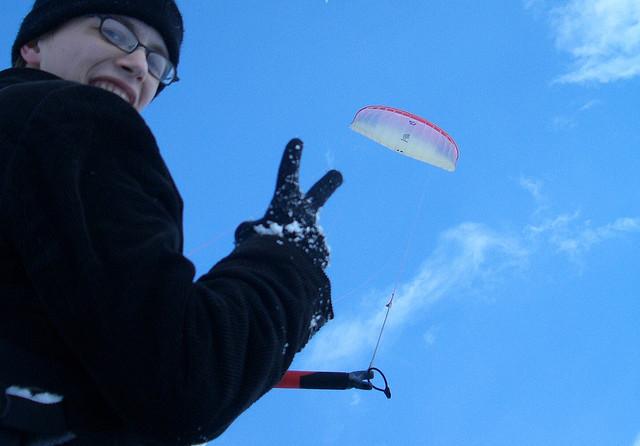What kind of sign is he making?
Short answer required. Peace. What is flying in the sky?
Be succinct. Kite. Is he wearing glasses?
Give a very brief answer. Yes. 